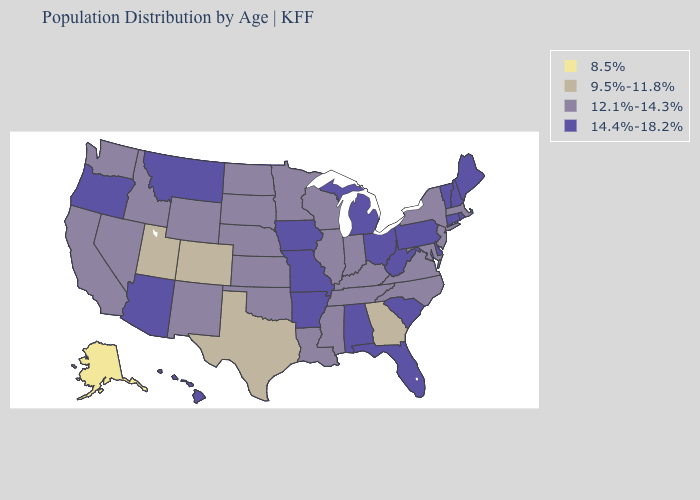Name the states that have a value in the range 14.4%-18.2%?
Answer briefly. Alabama, Arizona, Arkansas, Connecticut, Delaware, Florida, Hawaii, Iowa, Maine, Michigan, Missouri, Montana, New Hampshire, Ohio, Oregon, Pennsylvania, Rhode Island, South Carolina, Vermont, West Virginia. Name the states that have a value in the range 8.5%?
Keep it brief. Alaska. What is the value of Wisconsin?
Concise answer only. 12.1%-14.3%. What is the value of Alabama?
Answer briefly. 14.4%-18.2%. What is the value of Arizona?
Short answer required. 14.4%-18.2%. Does the first symbol in the legend represent the smallest category?
Give a very brief answer. Yes. Does West Virginia have the highest value in the South?
Keep it brief. Yes. Name the states that have a value in the range 8.5%?
Keep it brief. Alaska. What is the lowest value in states that border Ohio?
Keep it brief. 12.1%-14.3%. Does California have a higher value than Idaho?
Write a very short answer. No. Name the states that have a value in the range 14.4%-18.2%?
Quick response, please. Alabama, Arizona, Arkansas, Connecticut, Delaware, Florida, Hawaii, Iowa, Maine, Michigan, Missouri, Montana, New Hampshire, Ohio, Oregon, Pennsylvania, Rhode Island, South Carolina, Vermont, West Virginia. Name the states that have a value in the range 9.5%-11.8%?
Keep it brief. Colorado, Georgia, Texas, Utah. Name the states that have a value in the range 8.5%?
Quick response, please. Alaska. What is the value of New Jersey?
Write a very short answer. 12.1%-14.3%. What is the value of Colorado?
Keep it brief. 9.5%-11.8%. 